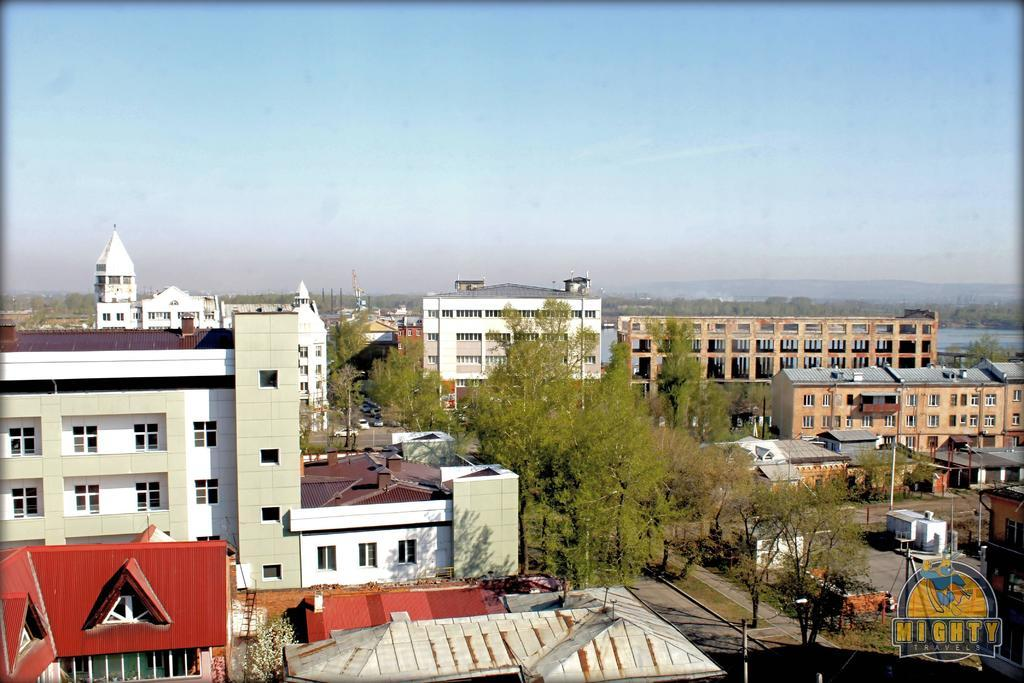What type of structures can be seen in the image? There are buildings in the image. What natural elements are present in the image? There are trees in the image. What man-made objects can be seen in the image? There are poles in the image. What type of transportation is visible in the image? There are cars in the image. What is visible in the background of the image? The sky is visible in the background of the image. Can you see any silk in the image? There is no silk present in the image. Is there a goat visible in the image? There is no goat present in the image. 